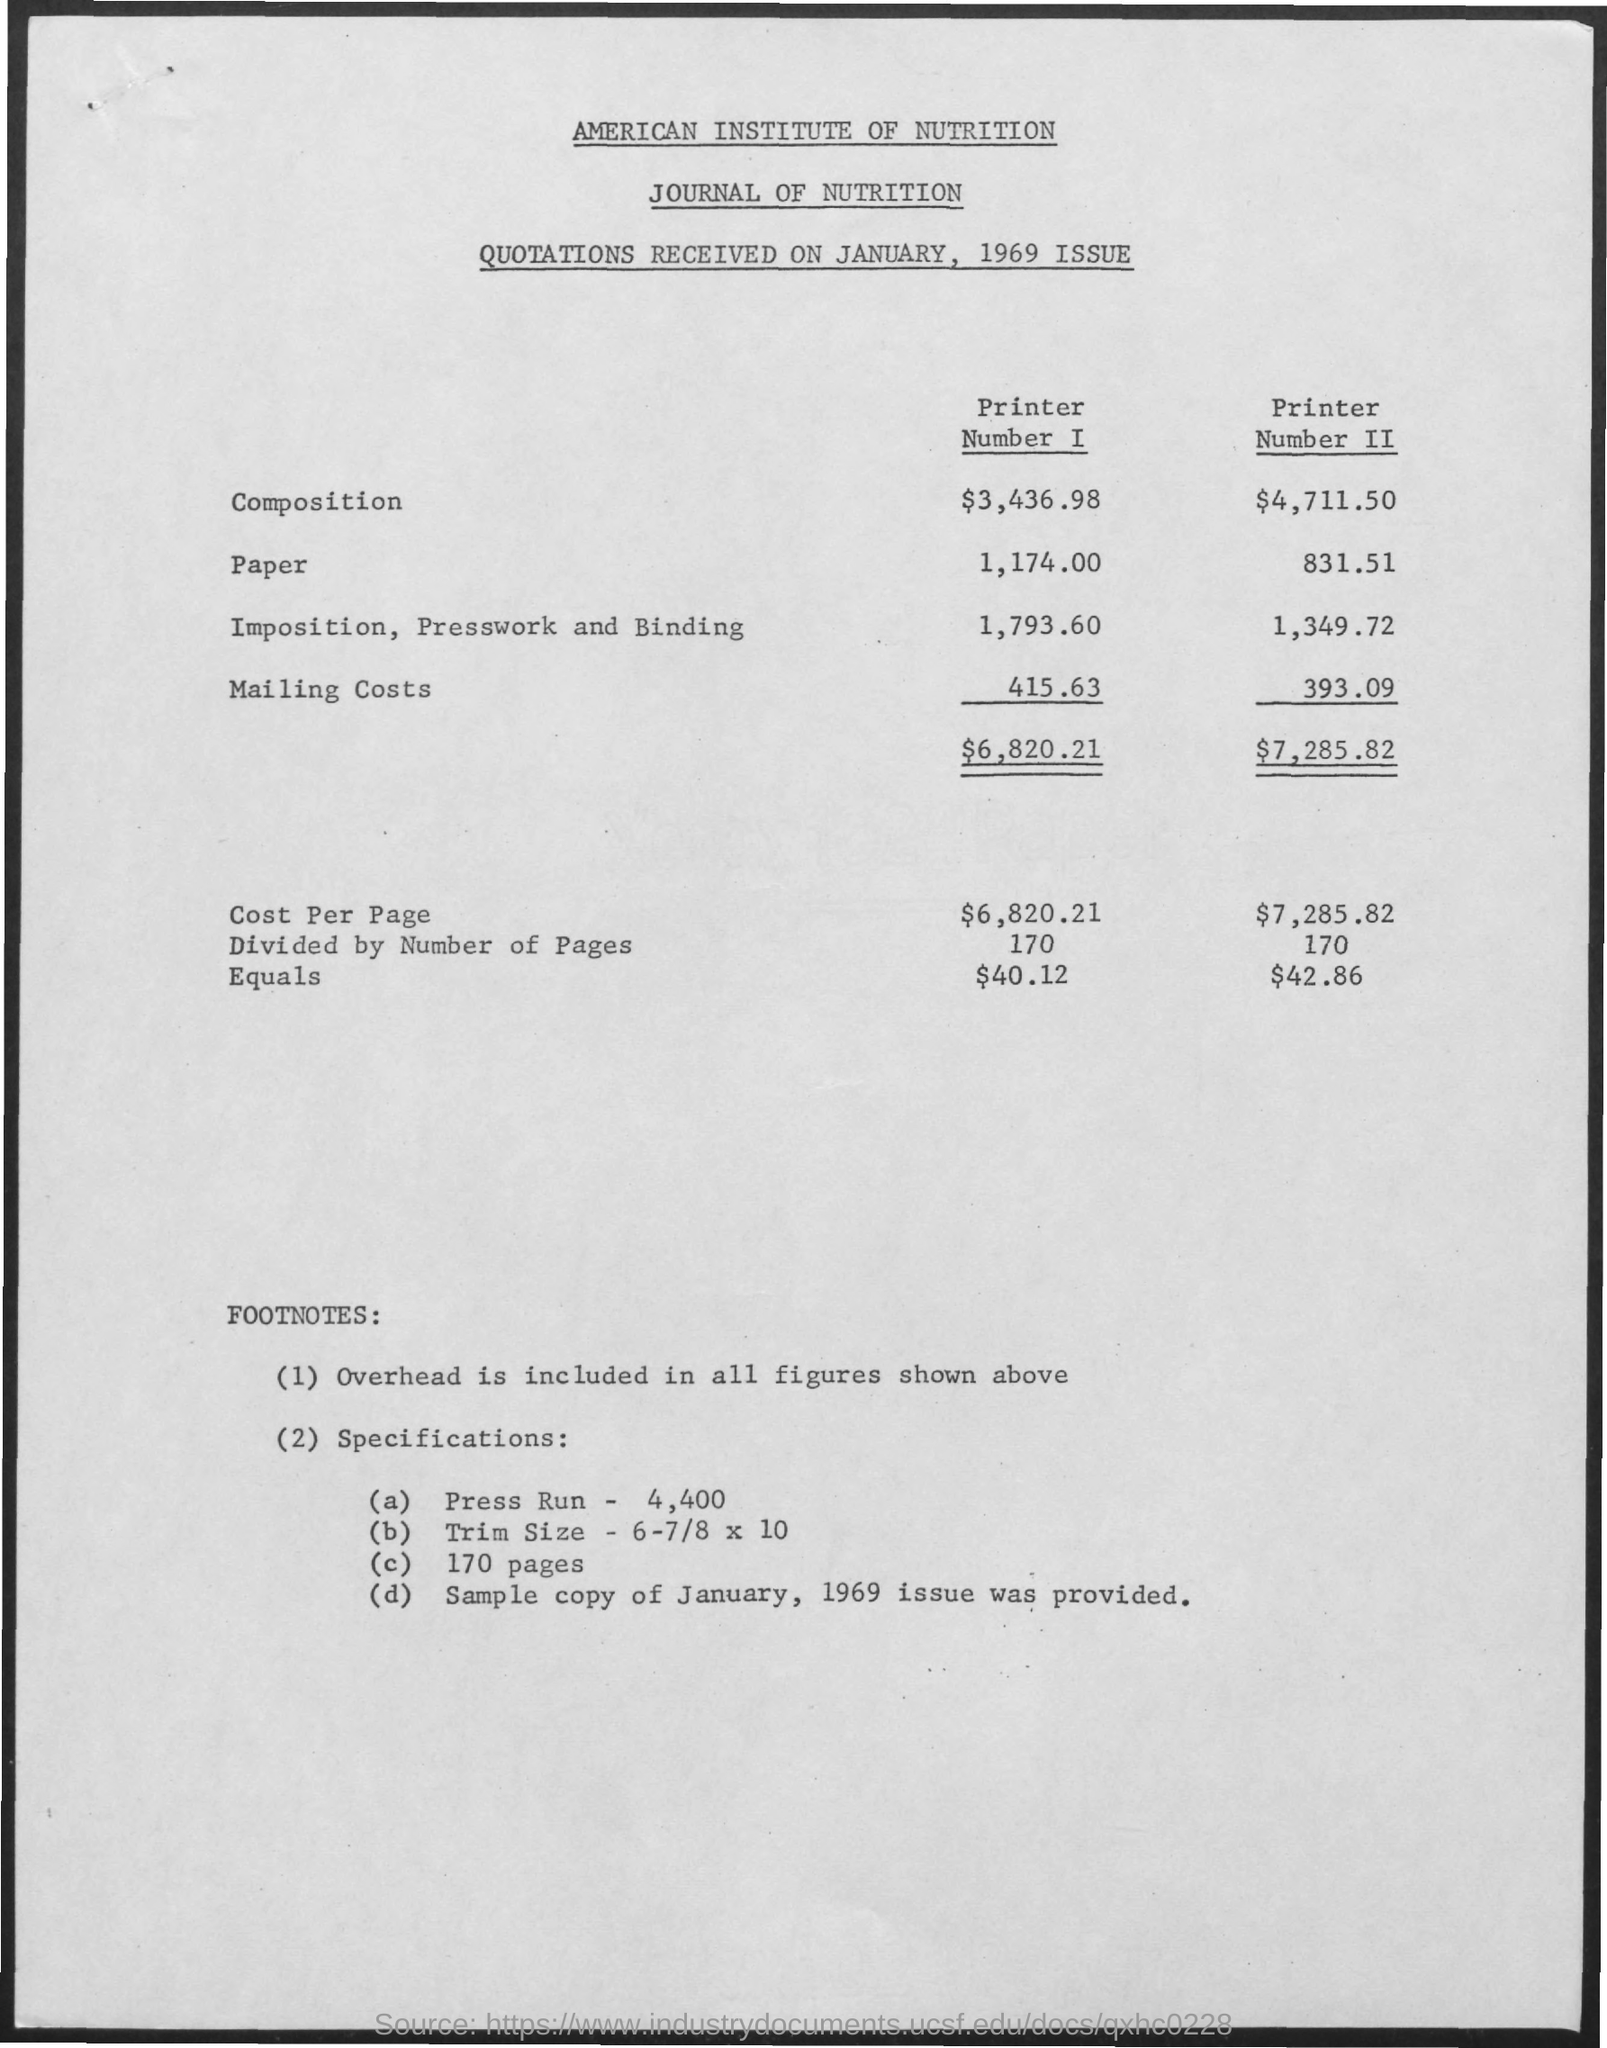Draw attention to some important aspects in this diagram. The cost per page for Printer Number I is $6,820.21. The cost per page for Printer Number II is $7,285.82. The mailing cost for Printer Number I is 415.63... The amount of composition for Printer number I is $3,436.98. The amount for paper for Printer Number I is 1,174.00. 